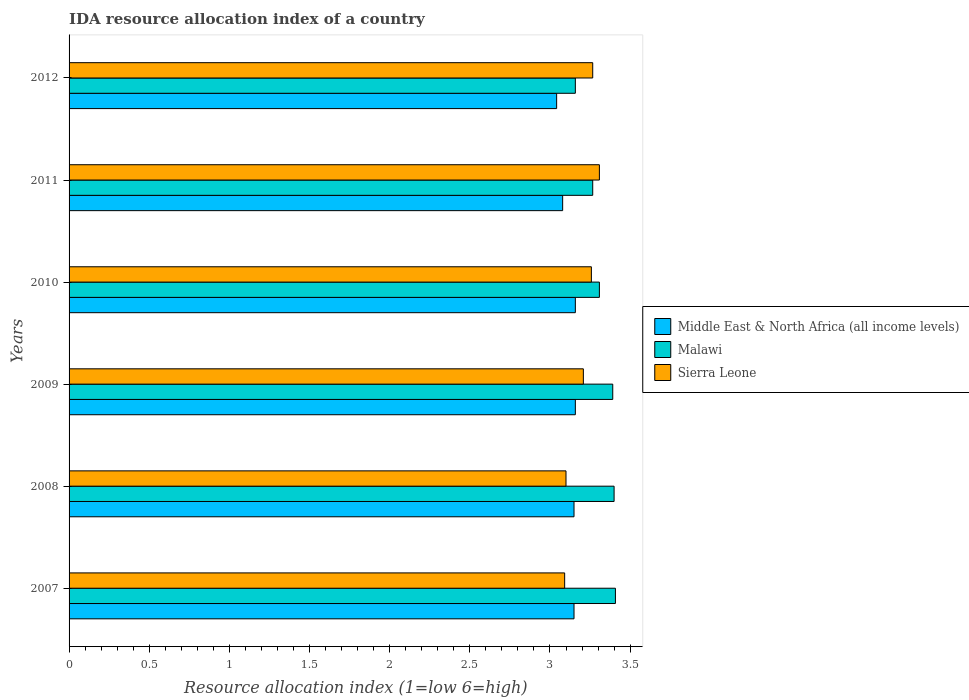How many groups of bars are there?
Provide a short and direct response. 6. Are the number of bars per tick equal to the number of legend labels?
Offer a very short reply. Yes. How many bars are there on the 3rd tick from the bottom?
Keep it short and to the point. 3. What is the label of the 3rd group of bars from the top?
Give a very brief answer. 2010. In how many cases, is the number of bars for a given year not equal to the number of legend labels?
Give a very brief answer. 0. What is the IDA resource allocation index in Malawi in 2008?
Your answer should be very brief. 3.4. Across all years, what is the maximum IDA resource allocation index in Malawi?
Offer a terse response. 3.41. Across all years, what is the minimum IDA resource allocation index in Sierra Leone?
Offer a very short reply. 3.09. What is the total IDA resource allocation index in Middle East & North Africa (all income levels) in the graph?
Make the answer very short. 18.74. What is the difference between the IDA resource allocation index in Sierra Leone in 2009 and that in 2012?
Give a very brief answer. -0.06. What is the difference between the IDA resource allocation index in Malawi in 2009 and the IDA resource allocation index in Sierra Leone in 2011?
Offer a terse response. 0.08. What is the average IDA resource allocation index in Middle East & North Africa (all income levels) per year?
Provide a succinct answer. 3.12. In the year 2008, what is the difference between the IDA resource allocation index in Malawi and IDA resource allocation index in Sierra Leone?
Your response must be concise. 0.3. What is the ratio of the IDA resource allocation index in Middle East & North Africa (all income levels) in 2009 to that in 2011?
Give a very brief answer. 1.03. Is the IDA resource allocation index in Sierra Leone in 2007 less than that in 2011?
Your response must be concise. Yes. Is the difference between the IDA resource allocation index in Malawi in 2009 and 2010 greater than the difference between the IDA resource allocation index in Sierra Leone in 2009 and 2010?
Your answer should be very brief. Yes. What is the difference between the highest and the second highest IDA resource allocation index in Malawi?
Your answer should be very brief. 0.01. What is the difference between the highest and the lowest IDA resource allocation index in Malawi?
Offer a terse response. 0.25. What does the 2nd bar from the top in 2007 represents?
Offer a very short reply. Malawi. What does the 3rd bar from the bottom in 2007 represents?
Provide a succinct answer. Sierra Leone. How many bars are there?
Ensure brevity in your answer.  18. Are all the bars in the graph horizontal?
Keep it short and to the point. Yes. How many years are there in the graph?
Your answer should be very brief. 6. Are the values on the major ticks of X-axis written in scientific E-notation?
Your answer should be very brief. No. Where does the legend appear in the graph?
Provide a succinct answer. Center right. How many legend labels are there?
Give a very brief answer. 3. What is the title of the graph?
Keep it short and to the point. IDA resource allocation index of a country. What is the label or title of the X-axis?
Your answer should be very brief. Resource allocation index (1=low 6=high). What is the label or title of the Y-axis?
Provide a short and direct response. Years. What is the Resource allocation index (1=low 6=high) in Middle East & North Africa (all income levels) in 2007?
Provide a short and direct response. 3.15. What is the Resource allocation index (1=low 6=high) in Malawi in 2007?
Your answer should be compact. 3.41. What is the Resource allocation index (1=low 6=high) of Sierra Leone in 2007?
Your answer should be very brief. 3.09. What is the Resource allocation index (1=low 6=high) in Middle East & North Africa (all income levels) in 2008?
Make the answer very short. 3.15. What is the Resource allocation index (1=low 6=high) in Malawi in 2008?
Ensure brevity in your answer.  3.4. What is the Resource allocation index (1=low 6=high) of Middle East & North Africa (all income levels) in 2009?
Your answer should be compact. 3.16. What is the Resource allocation index (1=low 6=high) in Malawi in 2009?
Offer a very short reply. 3.39. What is the Resource allocation index (1=low 6=high) in Sierra Leone in 2009?
Ensure brevity in your answer.  3.21. What is the Resource allocation index (1=low 6=high) in Middle East & North Africa (all income levels) in 2010?
Your answer should be very brief. 3.16. What is the Resource allocation index (1=low 6=high) in Malawi in 2010?
Ensure brevity in your answer.  3.31. What is the Resource allocation index (1=low 6=high) in Sierra Leone in 2010?
Give a very brief answer. 3.26. What is the Resource allocation index (1=low 6=high) in Middle East & North Africa (all income levels) in 2011?
Give a very brief answer. 3.08. What is the Resource allocation index (1=low 6=high) of Malawi in 2011?
Your answer should be very brief. 3.27. What is the Resource allocation index (1=low 6=high) of Sierra Leone in 2011?
Make the answer very short. 3.31. What is the Resource allocation index (1=low 6=high) in Middle East & North Africa (all income levels) in 2012?
Ensure brevity in your answer.  3.04. What is the Resource allocation index (1=low 6=high) in Malawi in 2012?
Offer a very short reply. 3.16. What is the Resource allocation index (1=low 6=high) in Sierra Leone in 2012?
Your response must be concise. 3.27. Across all years, what is the maximum Resource allocation index (1=low 6=high) of Middle East & North Africa (all income levels)?
Give a very brief answer. 3.16. Across all years, what is the maximum Resource allocation index (1=low 6=high) in Malawi?
Provide a short and direct response. 3.41. Across all years, what is the maximum Resource allocation index (1=low 6=high) in Sierra Leone?
Give a very brief answer. 3.31. Across all years, what is the minimum Resource allocation index (1=low 6=high) of Middle East & North Africa (all income levels)?
Make the answer very short. 3.04. Across all years, what is the minimum Resource allocation index (1=low 6=high) in Malawi?
Ensure brevity in your answer.  3.16. Across all years, what is the minimum Resource allocation index (1=low 6=high) in Sierra Leone?
Give a very brief answer. 3.09. What is the total Resource allocation index (1=low 6=high) of Middle East & North Africa (all income levels) in the graph?
Your answer should be very brief. 18.74. What is the total Resource allocation index (1=low 6=high) in Malawi in the graph?
Provide a short and direct response. 19.93. What is the total Resource allocation index (1=low 6=high) in Sierra Leone in the graph?
Give a very brief answer. 19.23. What is the difference between the Resource allocation index (1=low 6=high) of Malawi in 2007 and that in 2008?
Offer a terse response. 0.01. What is the difference between the Resource allocation index (1=low 6=high) in Sierra Leone in 2007 and that in 2008?
Offer a very short reply. -0.01. What is the difference between the Resource allocation index (1=low 6=high) of Middle East & North Africa (all income levels) in 2007 and that in 2009?
Your response must be concise. -0.01. What is the difference between the Resource allocation index (1=low 6=high) in Malawi in 2007 and that in 2009?
Make the answer very short. 0.02. What is the difference between the Resource allocation index (1=low 6=high) of Sierra Leone in 2007 and that in 2009?
Your response must be concise. -0.12. What is the difference between the Resource allocation index (1=low 6=high) in Middle East & North Africa (all income levels) in 2007 and that in 2010?
Provide a succinct answer. -0.01. What is the difference between the Resource allocation index (1=low 6=high) in Sierra Leone in 2007 and that in 2010?
Offer a terse response. -0.17. What is the difference between the Resource allocation index (1=low 6=high) in Middle East & North Africa (all income levels) in 2007 and that in 2011?
Your answer should be compact. 0.07. What is the difference between the Resource allocation index (1=low 6=high) of Malawi in 2007 and that in 2011?
Your answer should be compact. 0.14. What is the difference between the Resource allocation index (1=low 6=high) of Sierra Leone in 2007 and that in 2011?
Offer a terse response. -0.22. What is the difference between the Resource allocation index (1=low 6=high) of Middle East & North Africa (all income levels) in 2007 and that in 2012?
Offer a very short reply. 0.11. What is the difference between the Resource allocation index (1=low 6=high) in Malawi in 2007 and that in 2012?
Offer a very short reply. 0.25. What is the difference between the Resource allocation index (1=low 6=high) in Sierra Leone in 2007 and that in 2012?
Provide a short and direct response. -0.17. What is the difference between the Resource allocation index (1=low 6=high) in Middle East & North Africa (all income levels) in 2008 and that in 2009?
Offer a terse response. -0.01. What is the difference between the Resource allocation index (1=low 6=high) of Malawi in 2008 and that in 2009?
Ensure brevity in your answer.  0.01. What is the difference between the Resource allocation index (1=low 6=high) in Sierra Leone in 2008 and that in 2009?
Keep it short and to the point. -0.11. What is the difference between the Resource allocation index (1=low 6=high) in Middle East & North Africa (all income levels) in 2008 and that in 2010?
Make the answer very short. -0.01. What is the difference between the Resource allocation index (1=low 6=high) of Malawi in 2008 and that in 2010?
Offer a very short reply. 0.09. What is the difference between the Resource allocation index (1=low 6=high) of Sierra Leone in 2008 and that in 2010?
Keep it short and to the point. -0.16. What is the difference between the Resource allocation index (1=low 6=high) of Middle East & North Africa (all income levels) in 2008 and that in 2011?
Keep it short and to the point. 0.07. What is the difference between the Resource allocation index (1=low 6=high) of Malawi in 2008 and that in 2011?
Offer a terse response. 0.13. What is the difference between the Resource allocation index (1=low 6=high) of Sierra Leone in 2008 and that in 2011?
Keep it short and to the point. -0.21. What is the difference between the Resource allocation index (1=low 6=high) of Middle East & North Africa (all income levels) in 2008 and that in 2012?
Keep it short and to the point. 0.11. What is the difference between the Resource allocation index (1=low 6=high) in Malawi in 2008 and that in 2012?
Offer a terse response. 0.24. What is the difference between the Resource allocation index (1=low 6=high) in Malawi in 2009 and that in 2010?
Offer a terse response. 0.08. What is the difference between the Resource allocation index (1=low 6=high) of Sierra Leone in 2009 and that in 2010?
Make the answer very short. -0.05. What is the difference between the Resource allocation index (1=low 6=high) in Middle East & North Africa (all income levels) in 2009 and that in 2011?
Provide a short and direct response. 0.08. What is the difference between the Resource allocation index (1=low 6=high) of Malawi in 2009 and that in 2011?
Provide a short and direct response. 0.12. What is the difference between the Resource allocation index (1=low 6=high) of Sierra Leone in 2009 and that in 2011?
Make the answer very short. -0.1. What is the difference between the Resource allocation index (1=low 6=high) in Middle East & North Africa (all income levels) in 2009 and that in 2012?
Provide a short and direct response. 0.12. What is the difference between the Resource allocation index (1=low 6=high) of Malawi in 2009 and that in 2012?
Provide a short and direct response. 0.23. What is the difference between the Resource allocation index (1=low 6=high) of Sierra Leone in 2009 and that in 2012?
Make the answer very short. -0.06. What is the difference between the Resource allocation index (1=low 6=high) in Middle East & North Africa (all income levels) in 2010 and that in 2011?
Offer a very short reply. 0.08. What is the difference between the Resource allocation index (1=low 6=high) of Malawi in 2010 and that in 2011?
Your answer should be very brief. 0.04. What is the difference between the Resource allocation index (1=low 6=high) of Middle East & North Africa (all income levels) in 2010 and that in 2012?
Give a very brief answer. 0.12. What is the difference between the Resource allocation index (1=low 6=high) in Malawi in 2010 and that in 2012?
Make the answer very short. 0.15. What is the difference between the Resource allocation index (1=low 6=high) in Sierra Leone in 2010 and that in 2012?
Provide a succinct answer. -0.01. What is the difference between the Resource allocation index (1=low 6=high) in Middle East & North Africa (all income levels) in 2011 and that in 2012?
Your answer should be very brief. 0.04. What is the difference between the Resource allocation index (1=low 6=high) in Malawi in 2011 and that in 2012?
Give a very brief answer. 0.11. What is the difference between the Resource allocation index (1=low 6=high) in Sierra Leone in 2011 and that in 2012?
Your response must be concise. 0.04. What is the difference between the Resource allocation index (1=low 6=high) of Middle East & North Africa (all income levels) in 2007 and the Resource allocation index (1=low 6=high) of Malawi in 2008?
Keep it short and to the point. -0.25. What is the difference between the Resource allocation index (1=low 6=high) in Middle East & North Africa (all income levels) in 2007 and the Resource allocation index (1=low 6=high) in Sierra Leone in 2008?
Provide a succinct answer. 0.05. What is the difference between the Resource allocation index (1=low 6=high) in Malawi in 2007 and the Resource allocation index (1=low 6=high) in Sierra Leone in 2008?
Provide a succinct answer. 0.31. What is the difference between the Resource allocation index (1=low 6=high) in Middle East & North Africa (all income levels) in 2007 and the Resource allocation index (1=low 6=high) in Malawi in 2009?
Ensure brevity in your answer.  -0.24. What is the difference between the Resource allocation index (1=low 6=high) of Middle East & North Africa (all income levels) in 2007 and the Resource allocation index (1=low 6=high) of Sierra Leone in 2009?
Your answer should be compact. -0.06. What is the difference between the Resource allocation index (1=low 6=high) in Malawi in 2007 and the Resource allocation index (1=low 6=high) in Sierra Leone in 2009?
Keep it short and to the point. 0.2. What is the difference between the Resource allocation index (1=low 6=high) of Middle East & North Africa (all income levels) in 2007 and the Resource allocation index (1=low 6=high) of Malawi in 2010?
Keep it short and to the point. -0.16. What is the difference between the Resource allocation index (1=low 6=high) of Middle East & North Africa (all income levels) in 2007 and the Resource allocation index (1=low 6=high) of Sierra Leone in 2010?
Give a very brief answer. -0.11. What is the difference between the Resource allocation index (1=low 6=high) in Malawi in 2007 and the Resource allocation index (1=low 6=high) in Sierra Leone in 2010?
Make the answer very short. 0.15. What is the difference between the Resource allocation index (1=low 6=high) in Middle East & North Africa (all income levels) in 2007 and the Resource allocation index (1=low 6=high) in Malawi in 2011?
Keep it short and to the point. -0.12. What is the difference between the Resource allocation index (1=low 6=high) of Middle East & North Africa (all income levels) in 2007 and the Resource allocation index (1=low 6=high) of Sierra Leone in 2011?
Provide a short and direct response. -0.16. What is the difference between the Resource allocation index (1=low 6=high) of Middle East & North Africa (all income levels) in 2007 and the Resource allocation index (1=low 6=high) of Malawi in 2012?
Ensure brevity in your answer.  -0.01. What is the difference between the Resource allocation index (1=low 6=high) of Middle East & North Africa (all income levels) in 2007 and the Resource allocation index (1=low 6=high) of Sierra Leone in 2012?
Your answer should be compact. -0.12. What is the difference between the Resource allocation index (1=low 6=high) of Malawi in 2007 and the Resource allocation index (1=low 6=high) of Sierra Leone in 2012?
Keep it short and to the point. 0.14. What is the difference between the Resource allocation index (1=low 6=high) in Middle East & North Africa (all income levels) in 2008 and the Resource allocation index (1=low 6=high) in Malawi in 2009?
Give a very brief answer. -0.24. What is the difference between the Resource allocation index (1=low 6=high) of Middle East & North Africa (all income levels) in 2008 and the Resource allocation index (1=low 6=high) of Sierra Leone in 2009?
Ensure brevity in your answer.  -0.06. What is the difference between the Resource allocation index (1=low 6=high) of Malawi in 2008 and the Resource allocation index (1=low 6=high) of Sierra Leone in 2009?
Provide a short and direct response. 0.19. What is the difference between the Resource allocation index (1=low 6=high) in Middle East & North Africa (all income levels) in 2008 and the Resource allocation index (1=low 6=high) in Malawi in 2010?
Keep it short and to the point. -0.16. What is the difference between the Resource allocation index (1=low 6=high) in Middle East & North Africa (all income levels) in 2008 and the Resource allocation index (1=low 6=high) in Sierra Leone in 2010?
Your answer should be compact. -0.11. What is the difference between the Resource allocation index (1=low 6=high) in Malawi in 2008 and the Resource allocation index (1=low 6=high) in Sierra Leone in 2010?
Your answer should be compact. 0.14. What is the difference between the Resource allocation index (1=low 6=high) in Middle East & North Africa (all income levels) in 2008 and the Resource allocation index (1=low 6=high) in Malawi in 2011?
Keep it short and to the point. -0.12. What is the difference between the Resource allocation index (1=low 6=high) in Middle East & North Africa (all income levels) in 2008 and the Resource allocation index (1=low 6=high) in Sierra Leone in 2011?
Give a very brief answer. -0.16. What is the difference between the Resource allocation index (1=low 6=high) of Malawi in 2008 and the Resource allocation index (1=low 6=high) of Sierra Leone in 2011?
Your answer should be very brief. 0.09. What is the difference between the Resource allocation index (1=low 6=high) in Middle East & North Africa (all income levels) in 2008 and the Resource allocation index (1=low 6=high) in Malawi in 2012?
Provide a short and direct response. -0.01. What is the difference between the Resource allocation index (1=low 6=high) of Middle East & North Africa (all income levels) in 2008 and the Resource allocation index (1=low 6=high) of Sierra Leone in 2012?
Give a very brief answer. -0.12. What is the difference between the Resource allocation index (1=low 6=high) of Malawi in 2008 and the Resource allocation index (1=low 6=high) of Sierra Leone in 2012?
Offer a very short reply. 0.13. What is the difference between the Resource allocation index (1=low 6=high) of Middle East & North Africa (all income levels) in 2009 and the Resource allocation index (1=low 6=high) of Malawi in 2010?
Offer a terse response. -0.15. What is the difference between the Resource allocation index (1=low 6=high) of Middle East & North Africa (all income levels) in 2009 and the Resource allocation index (1=low 6=high) of Sierra Leone in 2010?
Your answer should be very brief. -0.1. What is the difference between the Resource allocation index (1=low 6=high) in Malawi in 2009 and the Resource allocation index (1=low 6=high) in Sierra Leone in 2010?
Your answer should be very brief. 0.13. What is the difference between the Resource allocation index (1=low 6=high) in Middle East & North Africa (all income levels) in 2009 and the Resource allocation index (1=low 6=high) in Malawi in 2011?
Your answer should be very brief. -0.11. What is the difference between the Resource allocation index (1=low 6=high) of Middle East & North Africa (all income levels) in 2009 and the Resource allocation index (1=low 6=high) of Sierra Leone in 2011?
Your response must be concise. -0.15. What is the difference between the Resource allocation index (1=low 6=high) in Malawi in 2009 and the Resource allocation index (1=low 6=high) in Sierra Leone in 2011?
Offer a very short reply. 0.08. What is the difference between the Resource allocation index (1=low 6=high) in Middle East & North Africa (all income levels) in 2009 and the Resource allocation index (1=low 6=high) in Sierra Leone in 2012?
Offer a very short reply. -0.11. What is the difference between the Resource allocation index (1=low 6=high) of Middle East & North Africa (all income levels) in 2010 and the Resource allocation index (1=low 6=high) of Malawi in 2011?
Your answer should be compact. -0.11. What is the difference between the Resource allocation index (1=low 6=high) of Middle East & North Africa (all income levels) in 2010 and the Resource allocation index (1=low 6=high) of Sierra Leone in 2011?
Keep it short and to the point. -0.15. What is the difference between the Resource allocation index (1=low 6=high) of Malawi in 2010 and the Resource allocation index (1=low 6=high) of Sierra Leone in 2011?
Ensure brevity in your answer.  0. What is the difference between the Resource allocation index (1=low 6=high) of Middle East & North Africa (all income levels) in 2010 and the Resource allocation index (1=low 6=high) of Sierra Leone in 2012?
Your answer should be very brief. -0.11. What is the difference between the Resource allocation index (1=low 6=high) of Malawi in 2010 and the Resource allocation index (1=low 6=high) of Sierra Leone in 2012?
Provide a succinct answer. 0.04. What is the difference between the Resource allocation index (1=low 6=high) of Middle East & North Africa (all income levels) in 2011 and the Resource allocation index (1=low 6=high) of Malawi in 2012?
Offer a very short reply. -0.08. What is the difference between the Resource allocation index (1=low 6=high) in Middle East & North Africa (all income levels) in 2011 and the Resource allocation index (1=low 6=high) in Sierra Leone in 2012?
Ensure brevity in your answer.  -0.19. What is the difference between the Resource allocation index (1=low 6=high) of Malawi in 2011 and the Resource allocation index (1=low 6=high) of Sierra Leone in 2012?
Ensure brevity in your answer.  0. What is the average Resource allocation index (1=low 6=high) in Middle East & North Africa (all income levels) per year?
Keep it short and to the point. 3.12. What is the average Resource allocation index (1=low 6=high) of Malawi per year?
Your answer should be very brief. 3.32. What is the average Resource allocation index (1=low 6=high) in Sierra Leone per year?
Your answer should be very brief. 3.21. In the year 2007, what is the difference between the Resource allocation index (1=low 6=high) of Middle East & North Africa (all income levels) and Resource allocation index (1=low 6=high) of Malawi?
Your response must be concise. -0.26. In the year 2007, what is the difference between the Resource allocation index (1=low 6=high) in Middle East & North Africa (all income levels) and Resource allocation index (1=low 6=high) in Sierra Leone?
Your response must be concise. 0.06. In the year 2007, what is the difference between the Resource allocation index (1=low 6=high) of Malawi and Resource allocation index (1=low 6=high) of Sierra Leone?
Your answer should be compact. 0.32. In the year 2008, what is the difference between the Resource allocation index (1=low 6=high) of Malawi and Resource allocation index (1=low 6=high) of Sierra Leone?
Offer a very short reply. 0.3. In the year 2009, what is the difference between the Resource allocation index (1=low 6=high) in Middle East & North Africa (all income levels) and Resource allocation index (1=low 6=high) in Malawi?
Keep it short and to the point. -0.23. In the year 2009, what is the difference between the Resource allocation index (1=low 6=high) in Middle East & North Africa (all income levels) and Resource allocation index (1=low 6=high) in Sierra Leone?
Your answer should be very brief. -0.05. In the year 2009, what is the difference between the Resource allocation index (1=low 6=high) in Malawi and Resource allocation index (1=low 6=high) in Sierra Leone?
Your answer should be very brief. 0.18. In the year 2010, what is the difference between the Resource allocation index (1=low 6=high) of Middle East & North Africa (all income levels) and Resource allocation index (1=low 6=high) of Malawi?
Provide a succinct answer. -0.15. In the year 2011, what is the difference between the Resource allocation index (1=low 6=high) in Middle East & North Africa (all income levels) and Resource allocation index (1=low 6=high) in Malawi?
Give a very brief answer. -0.19. In the year 2011, what is the difference between the Resource allocation index (1=low 6=high) in Middle East & North Africa (all income levels) and Resource allocation index (1=low 6=high) in Sierra Leone?
Make the answer very short. -0.23. In the year 2011, what is the difference between the Resource allocation index (1=low 6=high) of Malawi and Resource allocation index (1=low 6=high) of Sierra Leone?
Make the answer very short. -0.04. In the year 2012, what is the difference between the Resource allocation index (1=low 6=high) in Middle East & North Africa (all income levels) and Resource allocation index (1=low 6=high) in Malawi?
Offer a very short reply. -0.12. In the year 2012, what is the difference between the Resource allocation index (1=low 6=high) of Middle East & North Africa (all income levels) and Resource allocation index (1=low 6=high) of Sierra Leone?
Offer a terse response. -0.23. In the year 2012, what is the difference between the Resource allocation index (1=low 6=high) of Malawi and Resource allocation index (1=low 6=high) of Sierra Leone?
Offer a very short reply. -0.11. What is the ratio of the Resource allocation index (1=low 6=high) of Middle East & North Africa (all income levels) in 2007 to that in 2008?
Offer a terse response. 1. What is the ratio of the Resource allocation index (1=low 6=high) in Malawi in 2007 to that in 2008?
Provide a short and direct response. 1. What is the ratio of the Resource allocation index (1=low 6=high) in Middle East & North Africa (all income levels) in 2007 to that in 2009?
Your response must be concise. 1. What is the ratio of the Resource allocation index (1=low 6=high) of Sierra Leone in 2007 to that in 2009?
Keep it short and to the point. 0.96. What is the ratio of the Resource allocation index (1=low 6=high) in Middle East & North Africa (all income levels) in 2007 to that in 2010?
Your response must be concise. 1. What is the ratio of the Resource allocation index (1=low 6=high) of Malawi in 2007 to that in 2010?
Your answer should be very brief. 1.03. What is the ratio of the Resource allocation index (1=low 6=high) of Sierra Leone in 2007 to that in 2010?
Provide a short and direct response. 0.95. What is the ratio of the Resource allocation index (1=low 6=high) in Middle East & North Africa (all income levels) in 2007 to that in 2011?
Provide a short and direct response. 1.02. What is the ratio of the Resource allocation index (1=low 6=high) of Malawi in 2007 to that in 2011?
Your answer should be compact. 1.04. What is the ratio of the Resource allocation index (1=low 6=high) in Sierra Leone in 2007 to that in 2011?
Give a very brief answer. 0.93. What is the ratio of the Resource allocation index (1=low 6=high) in Middle East & North Africa (all income levels) in 2007 to that in 2012?
Keep it short and to the point. 1.04. What is the ratio of the Resource allocation index (1=low 6=high) of Malawi in 2007 to that in 2012?
Your answer should be compact. 1.08. What is the ratio of the Resource allocation index (1=low 6=high) in Sierra Leone in 2007 to that in 2012?
Offer a very short reply. 0.95. What is the ratio of the Resource allocation index (1=low 6=high) of Middle East & North Africa (all income levels) in 2008 to that in 2009?
Your answer should be compact. 1. What is the ratio of the Resource allocation index (1=low 6=high) in Malawi in 2008 to that in 2009?
Provide a succinct answer. 1. What is the ratio of the Resource allocation index (1=low 6=high) in Sierra Leone in 2008 to that in 2009?
Your answer should be compact. 0.97. What is the ratio of the Resource allocation index (1=low 6=high) in Malawi in 2008 to that in 2010?
Offer a terse response. 1.03. What is the ratio of the Resource allocation index (1=low 6=high) of Sierra Leone in 2008 to that in 2010?
Your response must be concise. 0.95. What is the ratio of the Resource allocation index (1=low 6=high) of Middle East & North Africa (all income levels) in 2008 to that in 2011?
Make the answer very short. 1.02. What is the ratio of the Resource allocation index (1=low 6=high) of Malawi in 2008 to that in 2011?
Make the answer very short. 1.04. What is the ratio of the Resource allocation index (1=low 6=high) in Sierra Leone in 2008 to that in 2011?
Your response must be concise. 0.94. What is the ratio of the Resource allocation index (1=low 6=high) in Middle East & North Africa (all income levels) in 2008 to that in 2012?
Provide a short and direct response. 1.04. What is the ratio of the Resource allocation index (1=low 6=high) of Malawi in 2008 to that in 2012?
Keep it short and to the point. 1.08. What is the ratio of the Resource allocation index (1=low 6=high) in Sierra Leone in 2008 to that in 2012?
Your answer should be very brief. 0.95. What is the ratio of the Resource allocation index (1=low 6=high) of Middle East & North Africa (all income levels) in 2009 to that in 2010?
Ensure brevity in your answer.  1. What is the ratio of the Resource allocation index (1=low 6=high) in Malawi in 2009 to that in 2010?
Provide a short and direct response. 1.03. What is the ratio of the Resource allocation index (1=low 6=high) in Sierra Leone in 2009 to that in 2010?
Your answer should be very brief. 0.98. What is the ratio of the Resource allocation index (1=low 6=high) in Middle East & North Africa (all income levels) in 2009 to that in 2011?
Give a very brief answer. 1.03. What is the ratio of the Resource allocation index (1=low 6=high) of Malawi in 2009 to that in 2011?
Make the answer very short. 1.04. What is the ratio of the Resource allocation index (1=low 6=high) of Sierra Leone in 2009 to that in 2011?
Give a very brief answer. 0.97. What is the ratio of the Resource allocation index (1=low 6=high) of Middle East & North Africa (all income levels) in 2009 to that in 2012?
Give a very brief answer. 1.04. What is the ratio of the Resource allocation index (1=low 6=high) in Malawi in 2009 to that in 2012?
Provide a short and direct response. 1.07. What is the ratio of the Resource allocation index (1=low 6=high) in Sierra Leone in 2009 to that in 2012?
Keep it short and to the point. 0.98. What is the ratio of the Resource allocation index (1=low 6=high) in Middle East & North Africa (all income levels) in 2010 to that in 2011?
Keep it short and to the point. 1.03. What is the ratio of the Resource allocation index (1=low 6=high) in Malawi in 2010 to that in 2011?
Keep it short and to the point. 1.01. What is the ratio of the Resource allocation index (1=low 6=high) of Sierra Leone in 2010 to that in 2011?
Your answer should be very brief. 0.98. What is the ratio of the Resource allocation index (1=low 6=high) in Middle East & North Africa (all income levels) in 2010 to that in 2012?
Provide a short and direct response. 1.04. What is the ratio of the Resource allocation index (1=low 6=high) in Malawi in 2010 to that in 2012?
Ensure brevity in your answer.  1.05. What is the ratio of the Resource allocation index (1=low 6=high) in Sierra Leone in 2010 to that in 2012?
Offer a very short reply. 1. What is the ratio of the Resource allocation index (1=low 6=high) of Middle East & North Africa (all income levels) in 2011 to that in 2012?
Make the answer very short. 1.01. What is the ratio of the Resource allocation index (1=low 6=high) of Malawi in 2011 to that in 2012?
Keep it short and to the point. 1.03. What is the ratio of the Resource allocation index (1=low 6=high) of Sierra Leone in 2011 to that in 2012?
Offer a terse response. 1.01. What is the difference between the highest and the second highest Resource allocation index (1=low 6=high) of Middle East & North Africa (all income levels)?
Make the answer very short. 0. What is the difference between the highest and the second highest Resource allocation index (1=low 6=high) of Malawi?
Provide a short and direct response. 0.01. What is the difference between the highest and the second highest Resource allocation index (1=low 6=high) of Sierra Leone?
Your answer should be very brief. 0.04. What is the difference between the highest and the lowest Resource allocation index (1=low 6=high) in Middle East & North Africa (all income levels)?
Your response must be concise. 0.12. What is the difference between the highest and the lowest Resource allocation index (1=low 6=high) in Sierra Leone?
Offer a terse response. 0.22. 